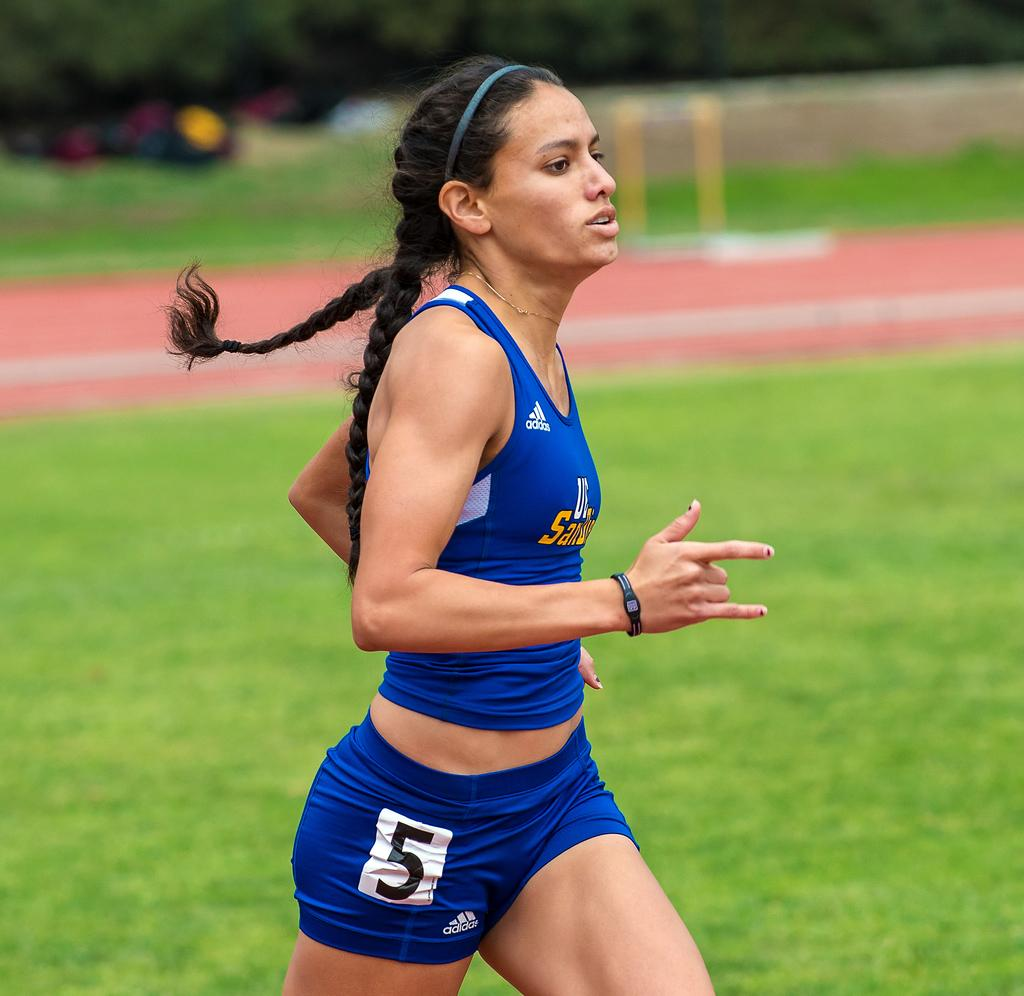<image>
Share a concise interpretation of the image provided. The female runner wears the number 5 on her shorts. 